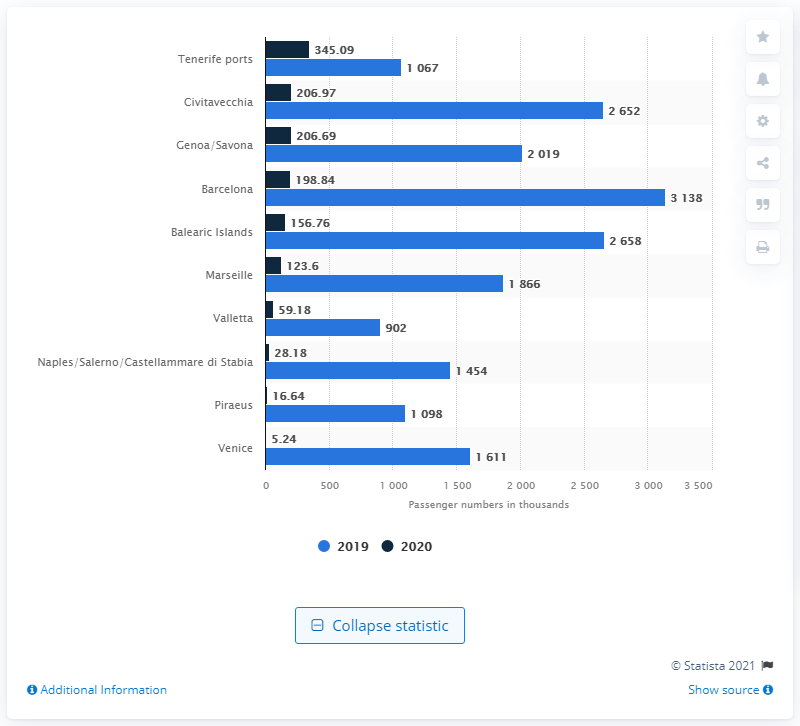Indicate a few pertinent items in this graphic. Barcelona is one of the leading Mediterranean cruise ports. 